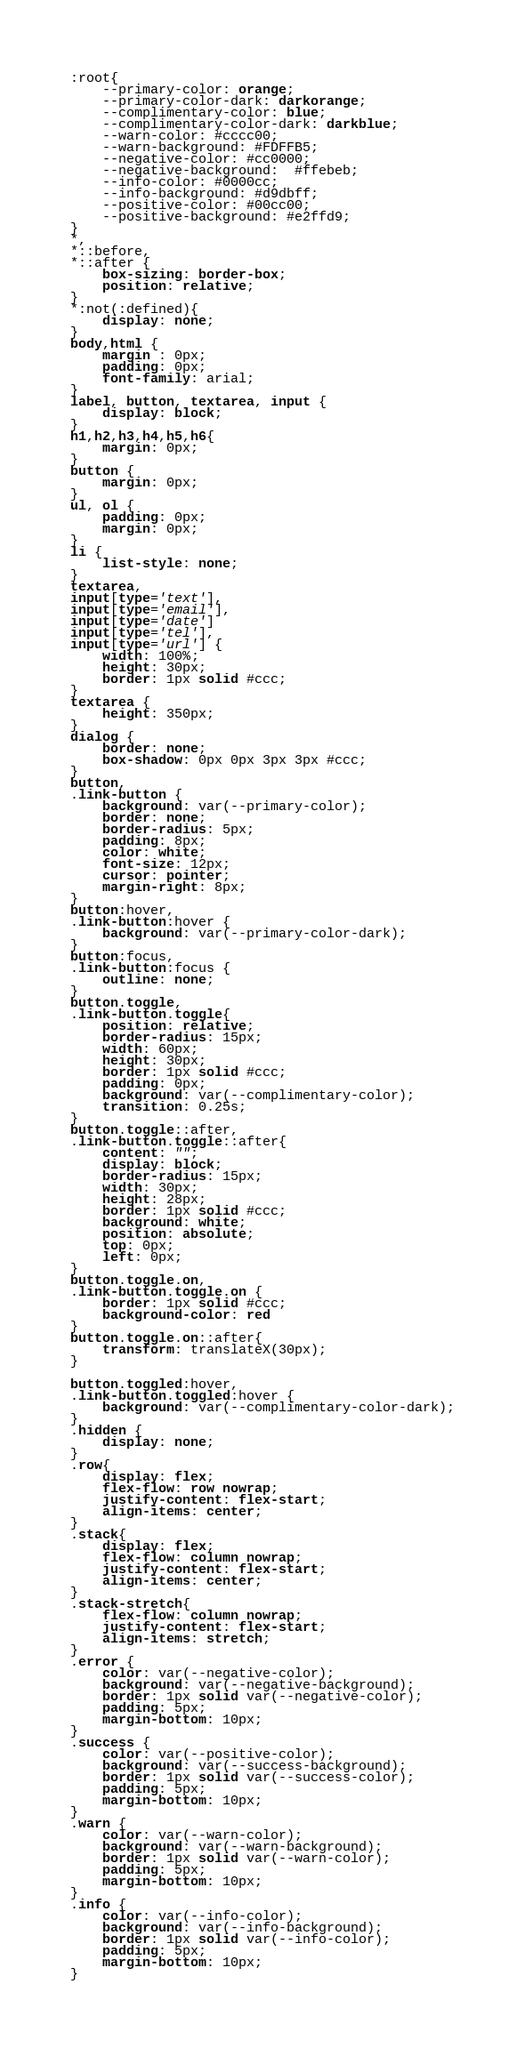Convert code to text. <code><loc_0><loc_0><loc_500><loc_500><_CSS_>:root{
	--primary-color: orange;
	--primary-color-dark: darkorange;
	--complimentary-color: blue;
	--complimentary-color-dark: darkblue;
	--warn-color: #cccc00;
	--warn-background: #FDFFB5;
	--negative-color: #cc0000;
	--negative-background:  #ffebeb;
	--info-color: #0000cc;
	--info-background: #d9dbff;
	--positive-color: #00cc00;
	--positive-background: #e2ffd9;
}
*,
*::before,
*::after {
	box-sizing: border-box;
	position: relative;
}
*:not(:defined){
	display: none;
}
body,html {
	margin : 0px;
	padding: 0px;
	font-family: arial;
}
label, button, textarea, input {
	display: block;
}
h1,h2,h3,h4,h5,h6{
	margin: 0px;
}
button {
	margin: 0px;
}
ul, ol {
	padding: 0px;
	margin: 0px;
}
li {
	list-style: none;
}
textarea,
input[type='text'],
input[type='email'],
input[type='date']
input[type='tel'],
input[type='url'] {
	width: 100%;
	height: 30px;
	border: 1px solid #ccc;
}
textarea {
	height: 350px;
}
dialog {
	border: none;
	box-shadow: 0px 0px 3px 3px #ccc;
}
button,
.link-button {
	background: var(--primary-color);
	border: none;
	border-radius: 5px;
	padding: 8px;
	color: white;
	font-size: 12px;
	cursor: pointer;
	margin-right: 8px;
}
button:hover,
.link-button:hover {
	background: var(--primary-color-dark);
}
button:focus,
.link-button:focus {
	outline: none;
}
button.toggle,
.link-button.toggle{
	position: relative;
	border-radius: 15px;
	width: 60px;
	height: 30px;
	border: 1px solid #ccc;
	padding: 0px;
	background: var(--complimentary-color);
	transition: 0.25s;
}
button.toggle::after,
.link-button.toggle::after{
	content: "";
	display: block;
	border-radius: 15px;
	width: 30px;
	height: 28px;
	border: 1px solid #ccc;
	background: white;
	position: absolute;
	top: 0px;
	left: 0px;
}
button.toggle.on,
.link-button.toggle.on {
	border: 1px solid #ccc;
	background-color: red
}
button.toggle.on::after{
	transform: translateX(30px);
}

button.toggled:hover,
.link-button.toggled:hover {
	background: var(--complimentary-color-dark);
}
.hidden {
	display: none;
}
.row{
	display: flex;
	flex-flow: row nowrap;
	justify-content: flex-start;
	align-items: center;
}
.stack{
	display: flex;
	flex-flow: column nowrap;
	justify-content: flex-start;
	align-items: center;
}
.stack-stretch{
	flex-flow: column nowrap;
	justify-content: flex-start;
	align-items: stretch;
}
.error {
	color: var(--negative-color);
	background: var(--negative-background);
	border: 1px solid var(--negative-color);
	padding: 5px;
	margin-bottom: 10px;
}
.success {
	color: var(--positive-color);
	background: var(--success-background);
	border: 1px solid var(--success-color);
	padding: 5px;
	margin-bottom: 10px;
}
.warn {
	color: var(--warn-color);
	background: var(--warn-background);
	border: 1px solid var(--warn-color);
	padding: 5px;
	margin-bottom: 10px;
}
.info {
	color: var(--info-color);
	background: var(--info-background);
	border: 1px solid var(--info-color);
	padding: 5px;
	margin-bottom: 10px;
}
</code> 